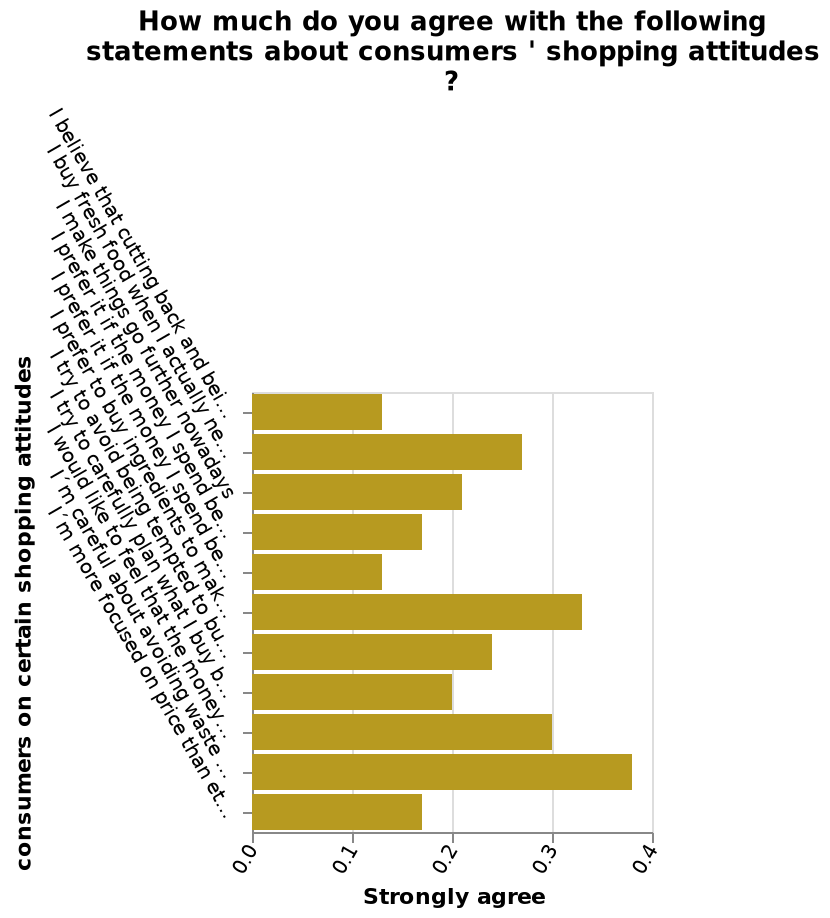<image>
please enumerates aspects of the construction of the chart This bar diagram is named How much do you agree with the following statements about consumers ' shopping attitudes ?. The y-axis plots consumers on certain shopping attitudes along categorical scale starting with I believe that cutting back and being more careful has made me a more environmentally friendly shopper and ending with I´m more focused on price than ethical or environmental considerations nowadays while the x-axis shows Strongly agree using linear scale with a minimum of 0.0 and a maximum of 0.4. How many categories are plotted on the y-axis? There is no specific mention of the number of categories plotted on the y-axis. What were consumers least likely to agree with? Consumers were least likely to agree with cutting back and prefer if money spent columns. What does the y-axis represent? The y-axis represents consumers' shopping attitudes along a categorical scale. What device was used to complete this figure? This figure was completed using a mobile phone. 